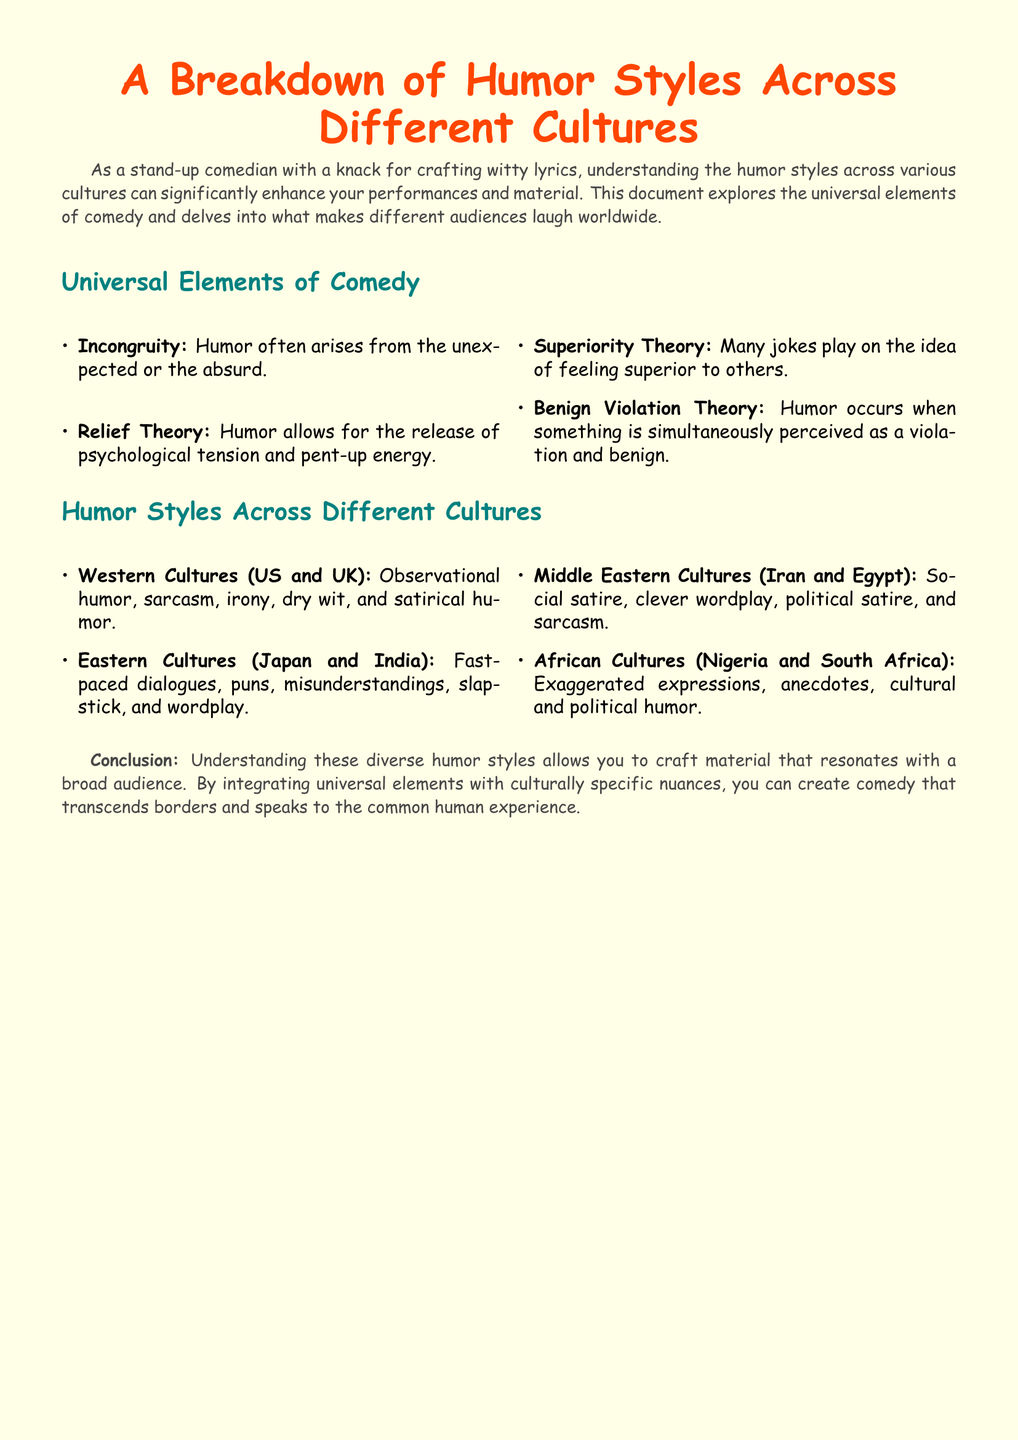What is the title of the document? The title indicates the focus of the document on humor styles and is prominently displayed.
Answer: A Breakdown of Humor Styles Across Different Cultures What are the four universal elements of comedy listed? The document outlines four theories related to humor that are considered universal.
Answer: Incongruity, Relief Theory, Superiority Theory, Benign Violation Theory Which cultures are associated with observational humor? The document specifies humor styles and connects them with different cultural backgrounds.
Answer: Western Cultures (US and UK) What type of humor is prominent in Eastern cultures? The document highlights specific humor styles found within Eastern cultures.
Answer: Fast-paced dialogues What conclusion is drawn in the document? The conclusion synthesizes the information and offers insight into how humor can be effectively crafted.
Answer: Understanding these diverse humor styles allows you to craft material that resonates with a broad audience Name one humor style identified in African cultures. The document gives examples of humor styles particular to African cultures.
Answer: Exaggerated expressions 